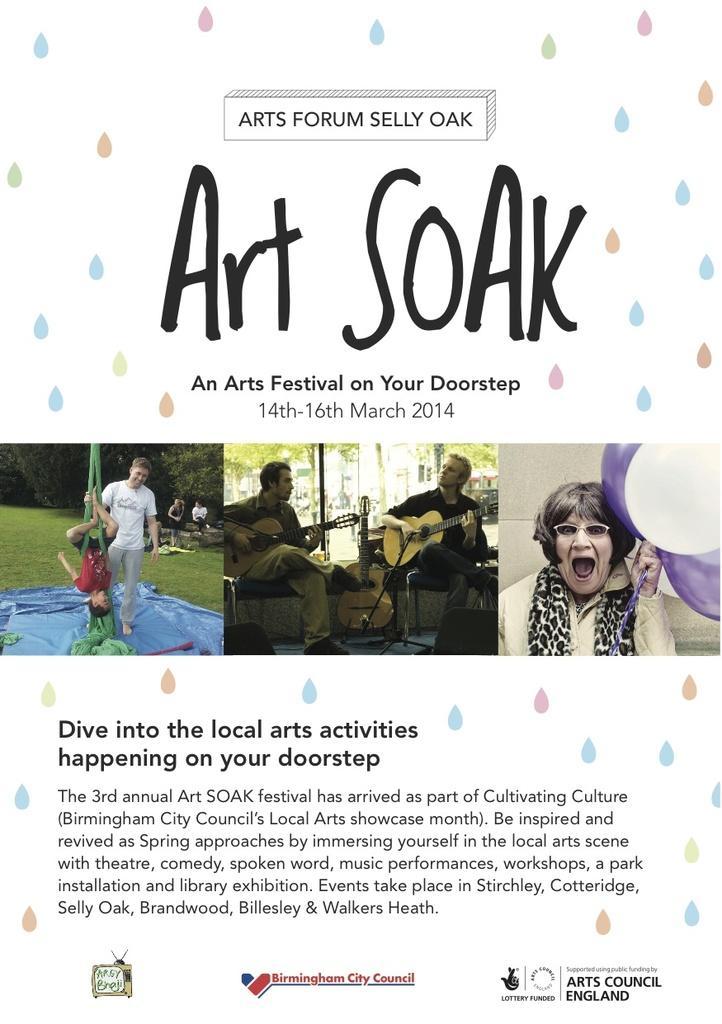Can you describe this image briefly? A picture consists of one slide in which in the middle there are two people are sitting and playing guitar and at the right corner one woman is holding balloons and wearing glasses and in the left corner one boy is hanging upside down from a cloth and one person is standing, behind him there are trees and in the slide there is some text. 